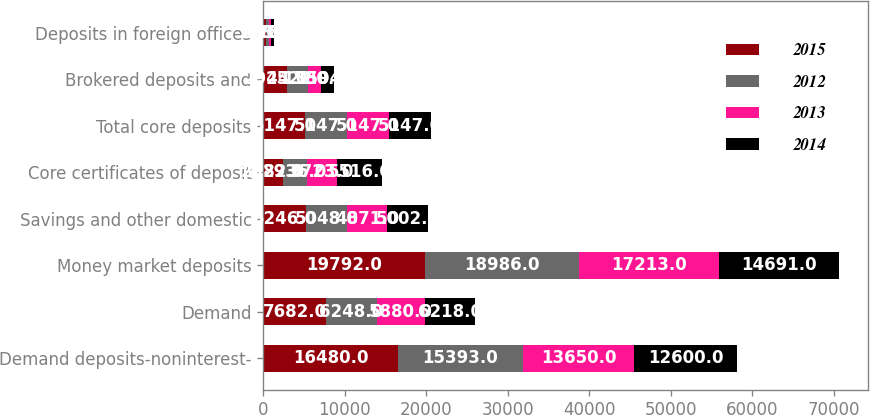Convert chart. <chart><loc_0><loc_0><loc_500><loc_500><stacked_bar_chart><ecel><fcel>Demand deposits-noninterest-<fcel>Demand<fcel>Money market deposits<fcel>Savings and other domestic<fcel>Core certificates of deposit<fcel>Total core deposits<fcel>Brokered deposits and<fcel>Deposits in foreign offices<nl><fcel>2015<fcel>16480<fcel>7682<fcel>19792<fcel>5246<fcel>2382<fcel>5147<fcel>2944<fcel>268<nl><fcel>2012<fcel>15393<fcel>6248<fcel>18986<fcel>5048<fcel>2936<fcel>5147<fcel>2522<fcel>401<nl><fcel>2013<fcel>13650<fcel>5880<fcel>17213<fcel>4871<fcel>3723<fcel>5147<fcel>1580<fcel>316<nl><fcel>2014<fcel>12600<fcel>6218<fcel>14691<fcel>5002<fcel>5516<fcel>5147<fcel>1594<fcel>278<nl></chart> 